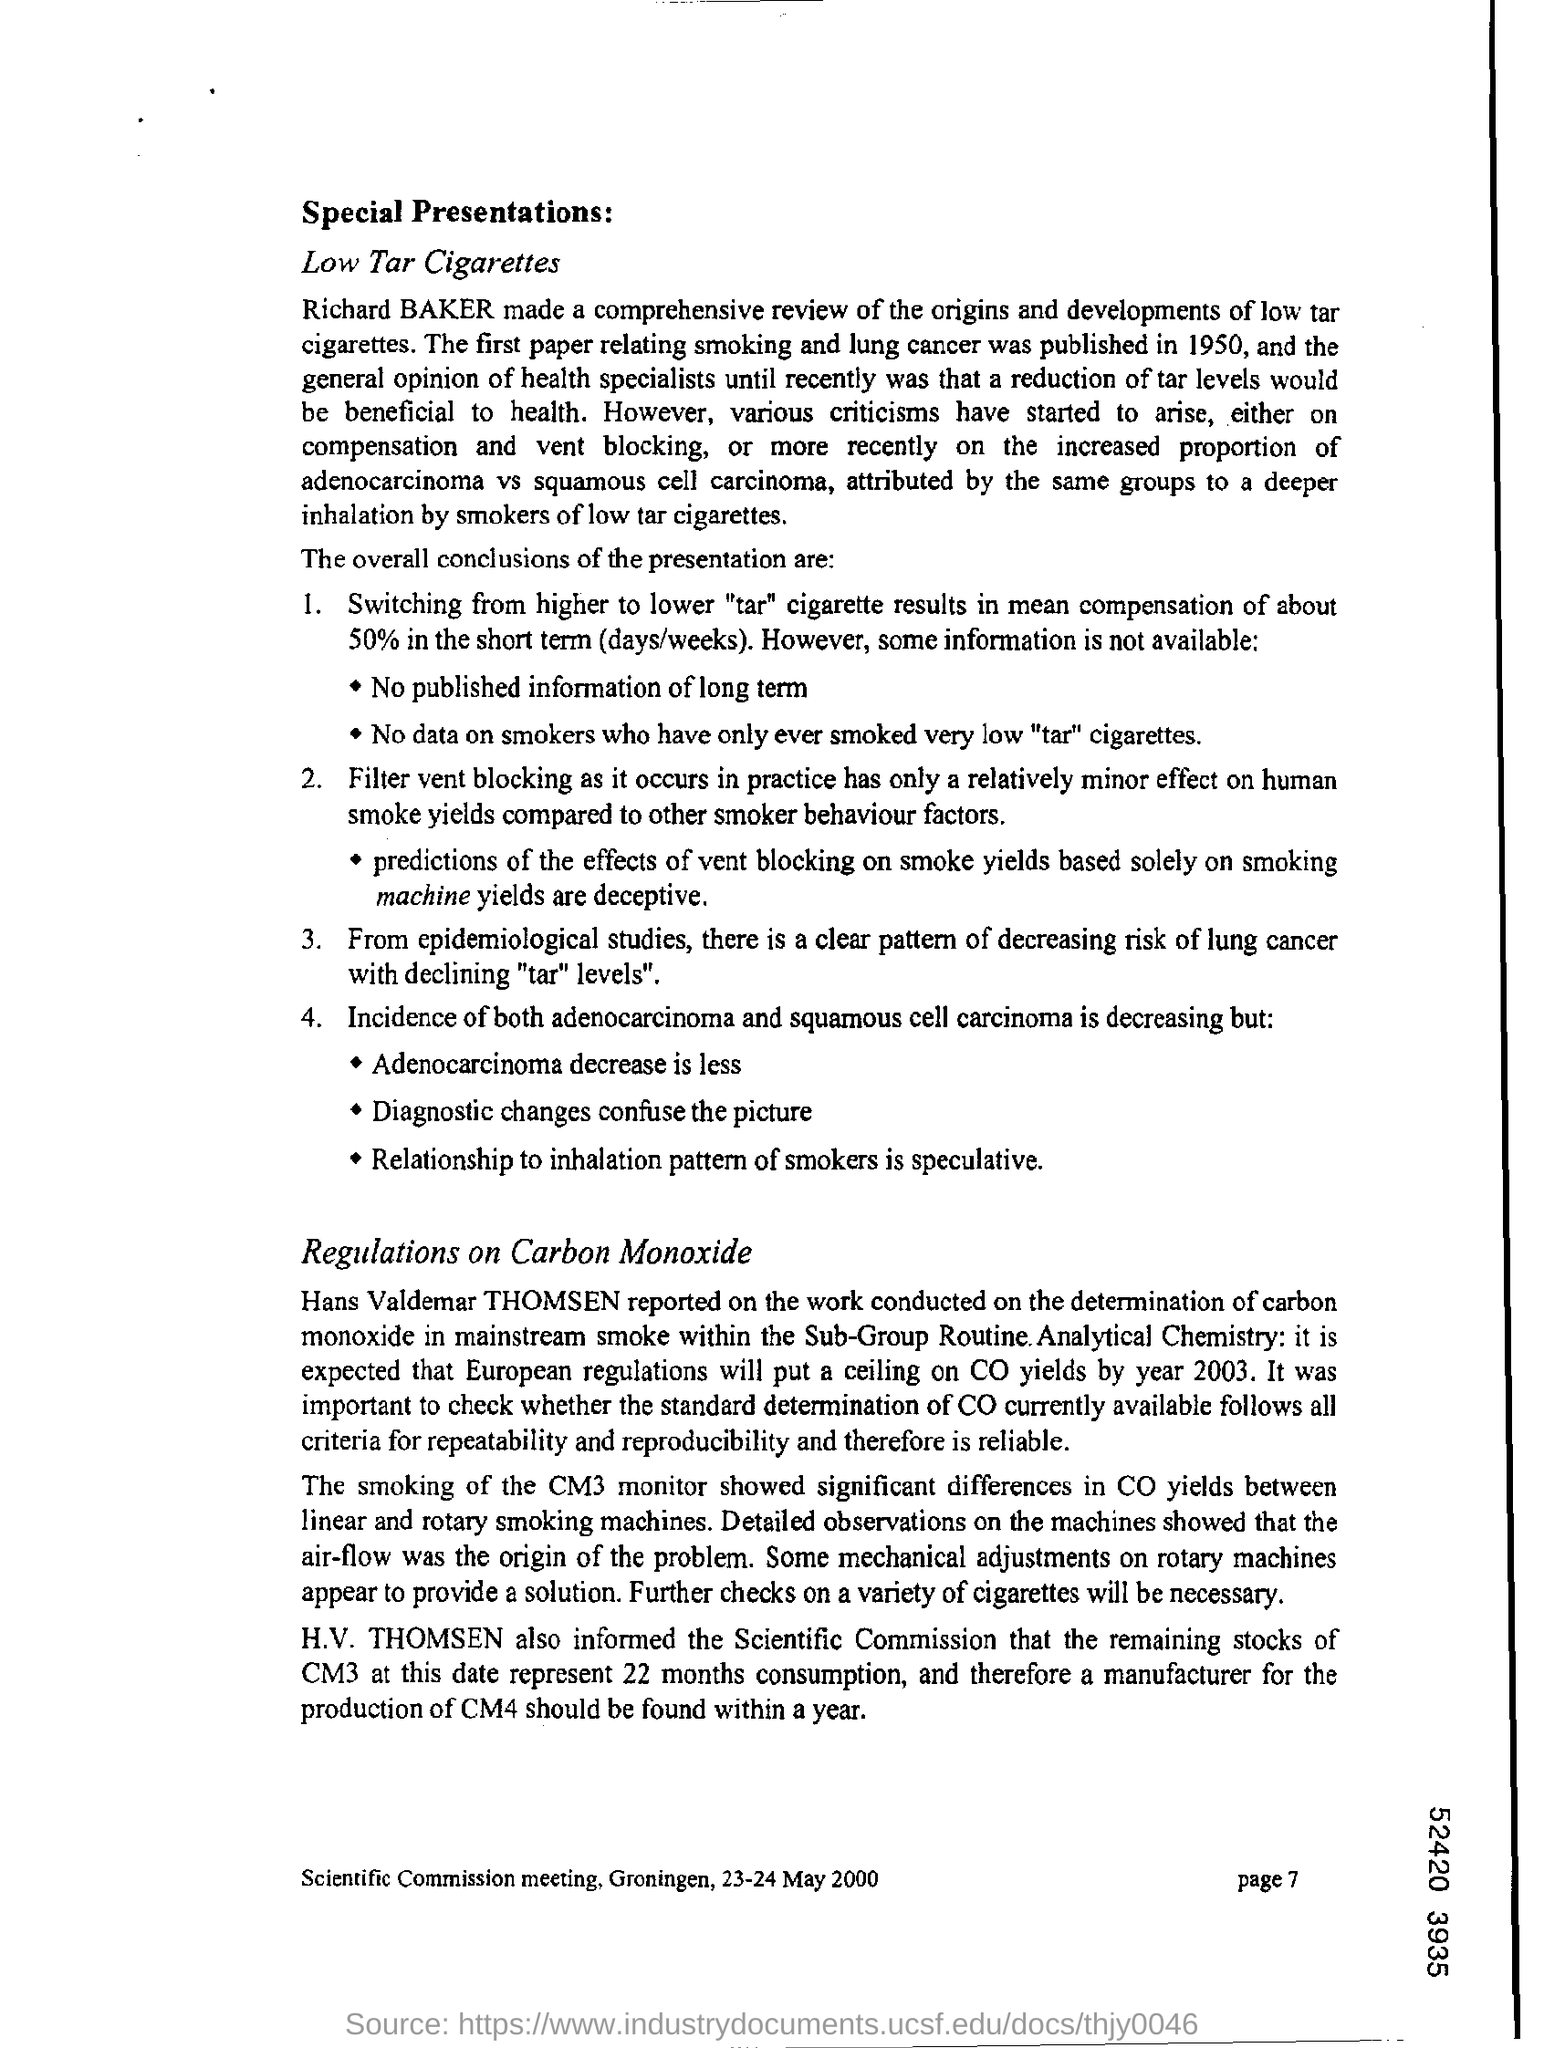List a handful of essential elements in this visual. It is necessary to mention the page number at the bottom right corner of each page. Richard Baker conducted a comprehensive review of the origins and developments of low tar cigarettes. 